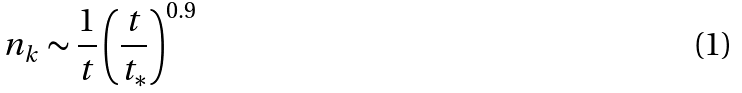<formula> <loc_0><loc_0><loc_500><loc_500>n _ { k } \sim \frac { 1 } { t } \left ( \frac { t } { t _ { * } } \right ) ^ { 0 . 9 }</formula> 